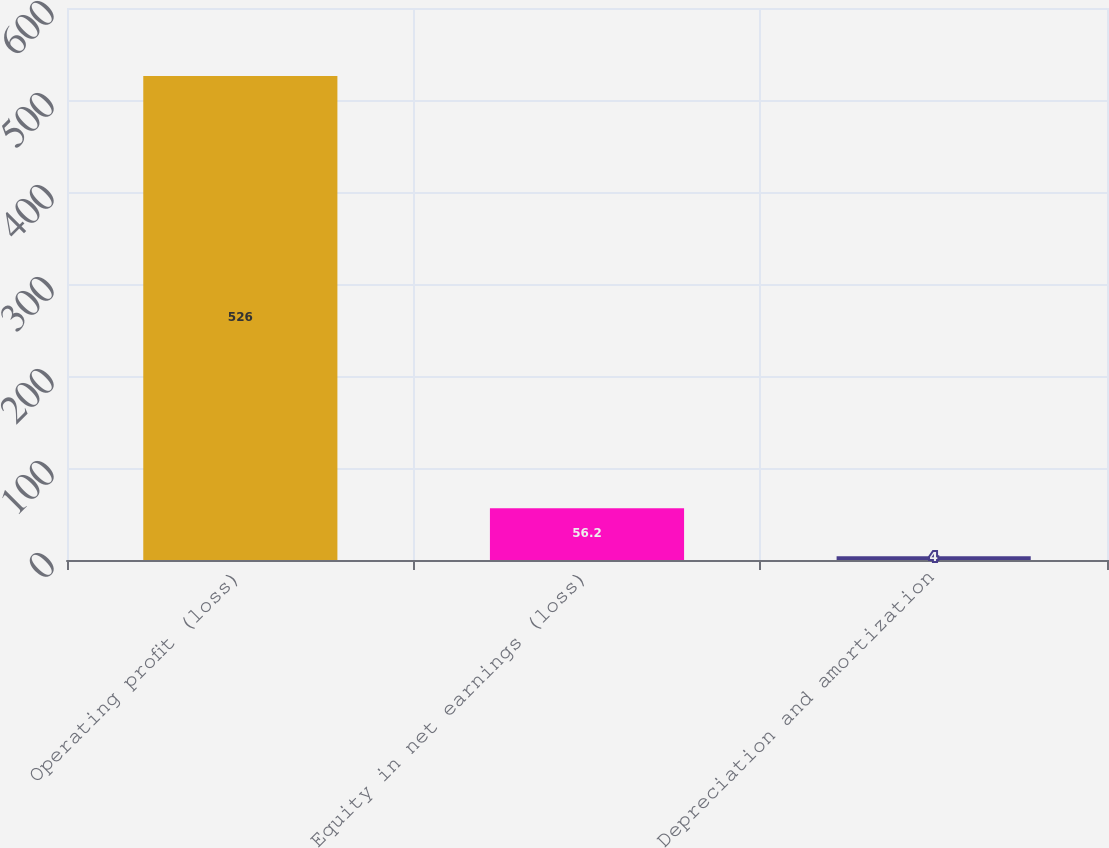Convert chart. <chart><loc_0><loc_0><loc_500><loc_500><bar_chart><fcel>Operating profit (loss)<fcel>Equity in net earnings (loss)<fcel>Depreciation and amortization<nl><fcel>526<fcel>56.2<fcel>4<nl></chart> 